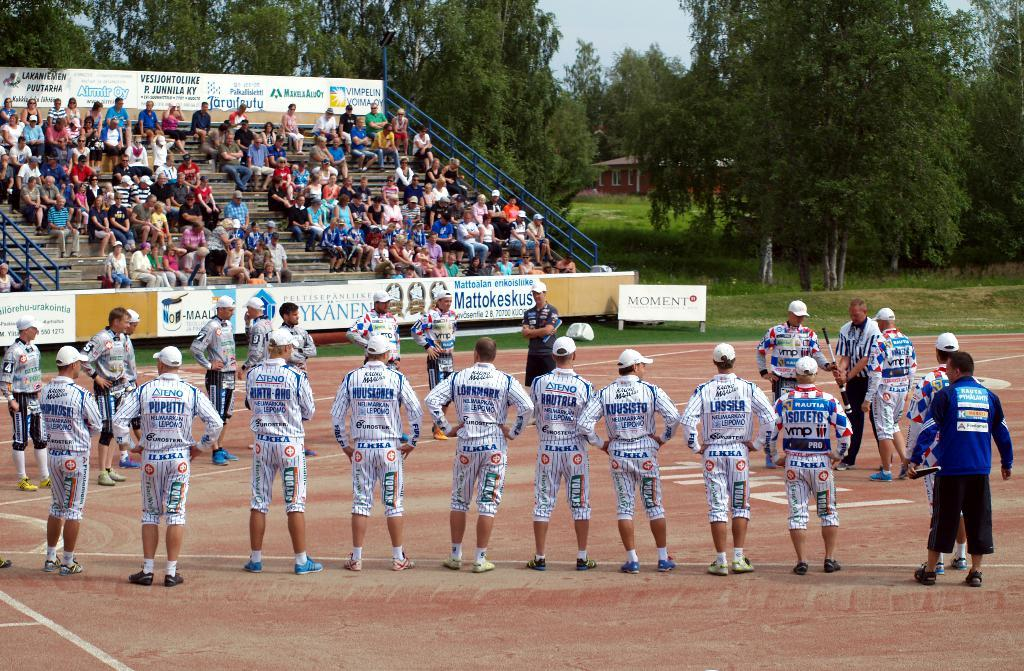<image>
Render a clear and concise summary of the photo. a person with pants that say Ilkha on them 